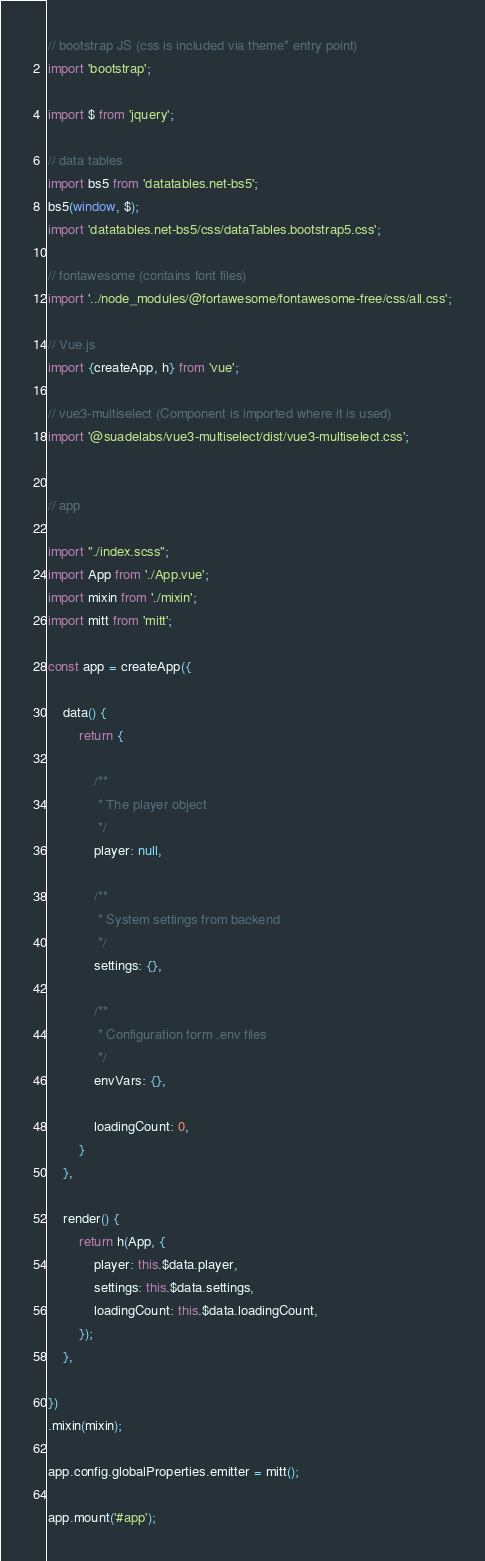<code> <loc_0><loc_0><loc_500><loc_500><_JavaScript_>
// bootstrap JS (css is included via theme* entry point)
import 'bootstrap';

import $ from 'jquery';

// data tables
import bs5 from 'datatables.net-bs5';
bs5(window, $);
import 'datatables.net-bs5/css/dataTables.bootstrap5.css';

// fontawesome (contains font files)
import '../node_modules/@fortawesome/fontawesome-free/css/all.css';

// Vue.js
import {createApp, h} from 'vue';

// vue3-multiselect (Component is imported where it is used)
import '@suadelabs/vue3-multiselect/dist/vue3-multiselect.css';


// app

import "./index.scss";
import App from './App.vue';
import mixin from './mixin';
import mitt from 'mitt';

const app = createApp({

    data() {
        return {

            /**
             * The player object
             */
            player: null,

            /**
             * System settings from backend
             */
            settings: {},

            /**
             * Configuration form .env files
             */
            envVars: {},

            loadingCount: 0,
        }
    },

    render() {
        return h(App, {
            player: this.$data.player,
            settings: this.$data.settings,
            loadingCount: this.$data.loadingCount,
        });
    },

})
.mixin(mixin);

app.config.globalProperties.emitter = mitt();

app.mount('#app');
</code> 